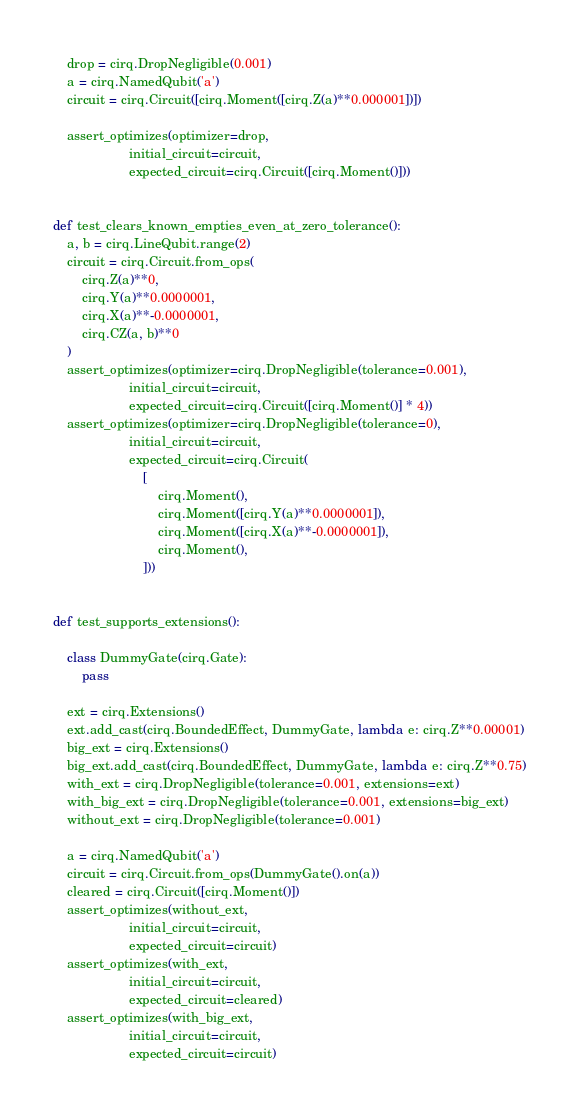<code> <loc_0><loc_0><loc_500><loc_500><_Python_>    drop = cirq.DropNegligible(0.001)
    a = cirq.NamedQubit('a')
    circuit = cirq.Circuit([cirq.Moment([cirq.Z(a)**0.000001])])

    assert_optimizes(optimizer=drop,
                     initial_circuit=circuit,
                     expected_circuit=cirq.Circuit([cirq.Moment()]))


def test_clears_known_empties_even_at_zero_tolerance():
    a, b = cirq.LineQubit.range(2)
    circuit = cirq.Circuit.from_ops(
        cirq.Z(a)**0,
        cirq.Y(a)**0.0000001,
        cirq.X(a)**-0.0000001,
        cirq.CZ(a, b)**0
    )
    assert_optimizes(optimizer=cirq.DropNegligible(tolerance=0.001),
                     initial_circuit=circuit,
                     expected_circuit=cirq.Circuit([cirq.Moment()] * 4))
    assert_optimizes(optimizer=cirq.DropNegligible(tolerance=0),
                     initial_circuit=circuit,
                     expected_circuit=cirq.Circuit(
                         [
                             cirq.Moment(),
                             cirq.Moment([cirq.Y(a)**0.0000001]),
                             cirq.Moment([cirq.X(a)**-0.0000001]),
                             cirq.Moment(),
                         ]))


def test_supports_extensions():

    class DummyGate(cirq.Gate):
        pass

    ext = cirq.Extensions()
    ext.add_cast(cirq.BoundedEffect, DummyGate, lambda e: cirq.Z**0.00001)
    big_ext = cirq.Extensions()
    big_ext.add_cast(cirq.BoundedEffect, DummyGate, lambda e: cirq.Z**0.75)
    with_ext = cirq.DropNegligible(tolerance=0.001, extensions=ext)
    with_big_ext = cirq.DropNegligible(tolerance=0.001, extensions=big_ext)
    without_ext = cirq.DropNegligible(tolerance=0.001)

    a = cirq.NamedQubit('a')
    circuit = cirq.Circuit.from_ops(DummyGate().on(a))
    cleared = cirq.Circuit([cirq.Moment()])
    assert_optimizes(without_ext,
                     initial_circuit=circuit,
                     expected_circuit=circuit)
    assert_optimizes(with_ext,
                     initial_circuit=circuit,
                     expected_circuit=cleared)
    assert_optimizes(with_big_ext,
                     initial_circuit=circuit,
                     expected_circuit=circuit)
</code> 